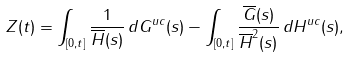Convert formula to latex. <formula><loc_0><loc_0><loc_500><loc_500>Z ( t ) = \int _ { [ 0 , t ] } \frac { 1 } { \overline { H } ( s ) } \, d G ^ { u c } ( s ) - \int _ { [ 0 , t ] } \frac { \overline { G } ( s ) } { \overline { H } ^ { 2 } ( s ) } \, d { H } ^ { u c } ( s ) ,</formula> 